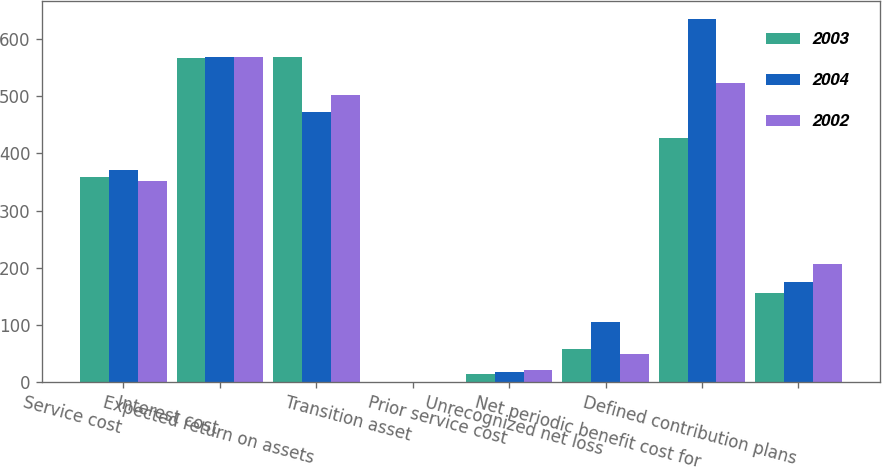Convert chart. <chart><loc_0><loc_0><loc_500><loc_500><stacked_bar_chart><ecel><fcel>Service cost<fcel>Interest cost<fcel>Expected return on assets<fcel>Transition asset<fcel>Prior service cost<fcel>Unrecognized net loss<fcel>Net periodic benefit cost for<fcel>Defined contribution plans<nl><fcel>2003<fcel>358<fcel>567<fcel>569<fcel>1<fcel>14<fcel>58<fcel>427<fcel>156<nl><fcel>2004<fcel>370<fcel>569<fcel>473<fcel>1<fcel>18<fcel>106<fcel>635<fcel>175<nl><fcel>2002<fcel>352<fcel>569<fcel>501<fcel>1<fcel>21<fcel>49<fcel>522<fcel>207<nl></chart> 